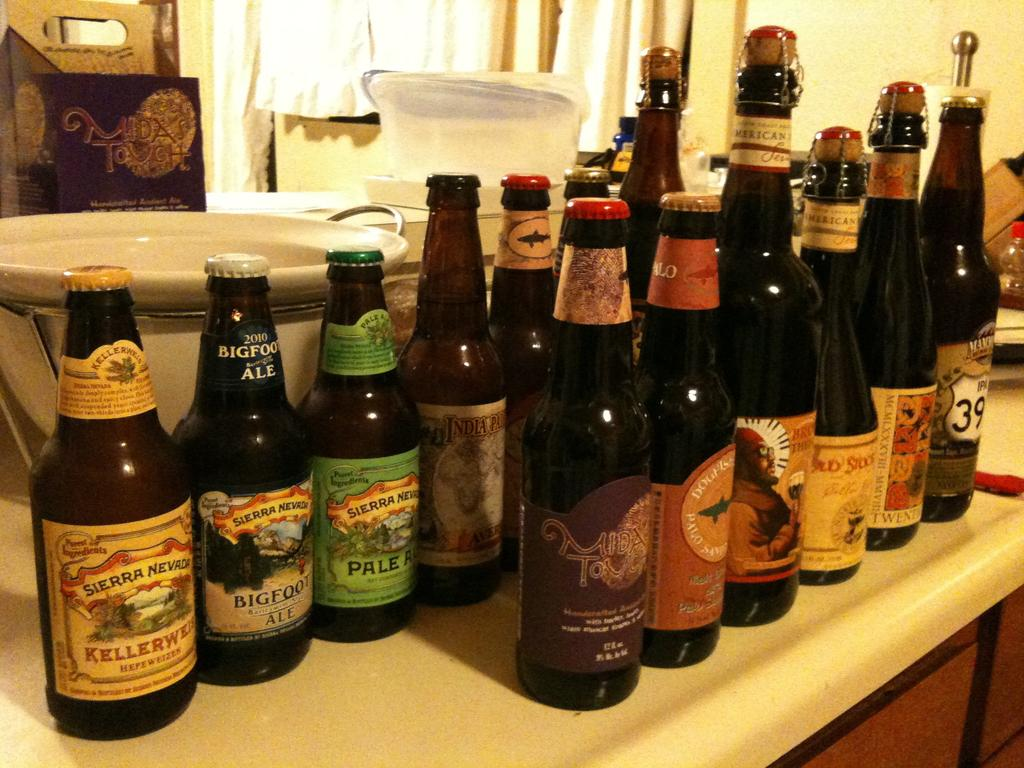<image>
Render a clear and concise summary of the photo. Several different bottles of alcohol are seen including a bottle of Sierra Nevada Pale Ale. 